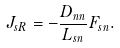Convert formula to latex. <formula><loc_0><loc_0><loc_500><loc_500>J _ { s R } = - \frac { D _ { n n } } { L _ { s n } } F _ { s n } .</formula> 